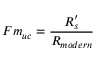<formula> <loc_0><loc_0><loc_500><loc_500>F m _ { u c } = { \frac { R _ { s } ^ { \prime } } { R _ { m o d e r n } } }</formula> 